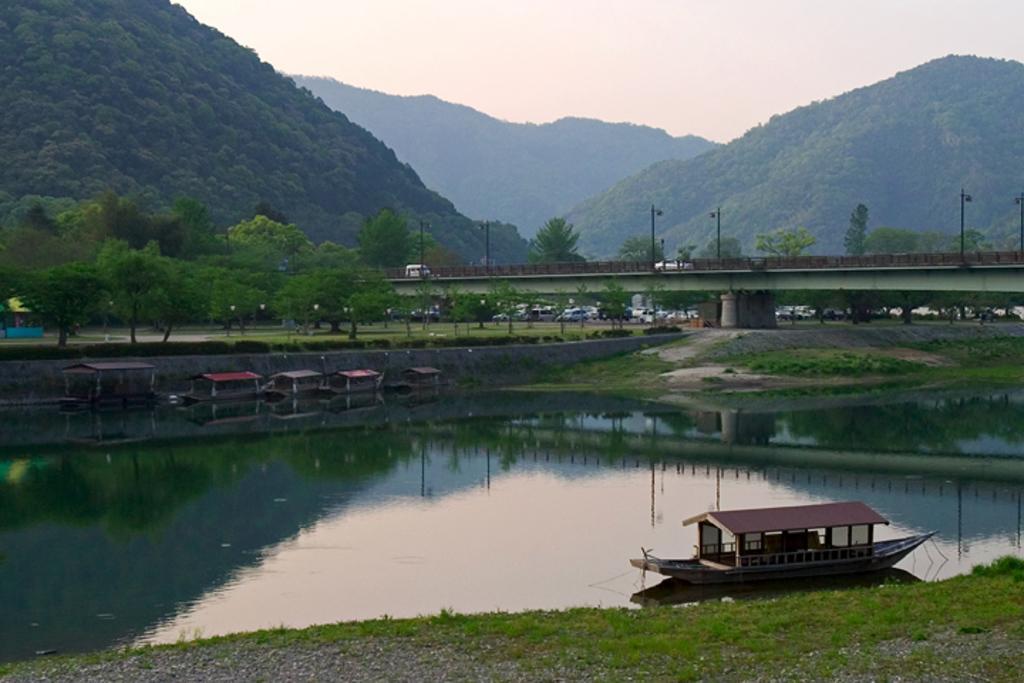Please provide a concise description of this image. In this image at the bottom there is one pond in that pond there is one boat, and at the bottom there is grass in the background there are some vehicles, trees and in the center there is one bridge and some poles. In the background there are some mountains and at the top of the image there is sky. 